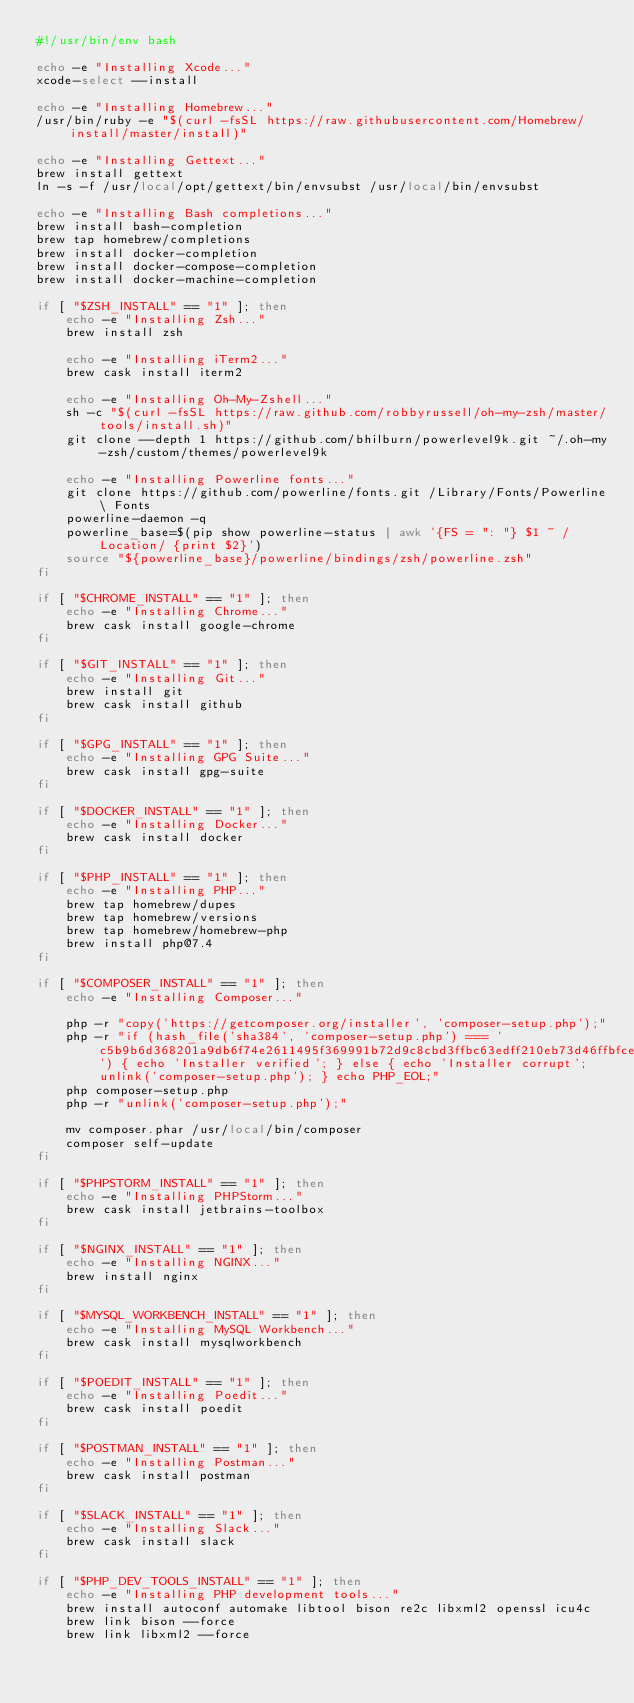<code> <loc_0><loc_0><loc_500><loc_500><_Bash_>#!/usr/bin/env bash

echo -e "Installing Xcode..."
xcode-select --install

echo -e "Installing Homebrew..."
/usr/bin/ruby -e "$(curl -fsSL https://raw.githubusercontent.com/Homebrew/install/master/install)"

echo -e "Installing Gettext..."
brew install gettext
ln -s -f /usr/local/opt/gettext/bin/envsubst /usr/local/bin/envsubst

echo -e "Installing Bash completions..."
brew install bash-completion
brew tap homebrew/completions
brew install docker-completion
brew install docker-compose-completion
brew install docker-machine-completion

if [ "$ZSH_INSTALL" == "1" ]; then
    echo -e "Installing Zsh..."
    brew install zsh

    echo -e "Installing iTerm2..."
    brew cask install iterm2

    echo -e "Installing Oh-My-Zshell..."
    sh -c "$(curl -fsSL https://raw.github.com/robbyrussell/oh-my-zsh/master/tools/install.sh)"
    git clone --depth 1 https://github.com/bhilburn/powerlevel9k.git ~/.oh-my-zsh/custom/themes/powerlevel9k

    echo -e "Installing Powerline fonts..."
    git clone https://github.com/powerline/fonts.git /Library/Fonts/Powerline\ Fonts
    powerline-daemon -q
    powerline_base=$(pip show powerline-status | awk '{FS = ": "} $1 ~ /Location/ {print $2}')
    source "${powerline_base}/powerline/bindings/zsh/powerline.zsh"
fi

if [ "$CHROME_INSTALL" == "1" ]; then
    echo -e "Installing Chrome..."
    brew cask install google-chrome
fi

if [ "$GIT_INSTALL" == "1" ]; then
    echo -e "Installing Git..."
    brew install git
    brew cask install github
fi

if [ "$GPG_INSTALL" == "1" ]; then
    echo -e "Installing GPG Suite..."
    brew cask install gpg-suite
fi

if [ "$DOCKER_INSTALL" == "1" ]; then
    echo -e "Installing Docker..."
    brew cask install docker
fi

if [ "$PHP_INSTALL" == "1" ]; then
    echo -e "Installing PHP..."
    brew tap homebrew/dupes
    brew tap homebrew/versions
    brew tap homebrew/homebrew-php
    brew install php@7.4
fi

if [ "$COMPOSER_INSTALL" == "1" ]; then
    echo -e "Installing Composer..."
    
    php -r "copy('https://getcomposer.org/installer', 'composer-setup.php');"
    php -r "if (hash_file('sha384', 'composer-setup.php') === 'c5b9b6d368201a9db6f74e2611495f369991b72d9c8cbd3ffbc63edff210eb73d46ffbfce88669ad33695ef77dc76976') { echo 'Installer verified'; } else { echo 'Installer corrupt'; unlink('composer-setup.php'); } echo PHP_EOL;"
    php composer-setup.php
    php -r "unlink('composer-setup.php');"

    mv composer.phar /usr/local/bin/composer
    composer self-update
fi

if [ "$PHPSTORM_INSTALL" == "1" ]; then
    echo -e "Installing PHPStorm..."
    brew cask install jetbrains-toolbox
fi

if [ "$NGINX_INSTALL" == "1" ]; then
    echo -e "Installing NGINX..."
    brew install nginx
fi

if [ "$MYSQL_WORKBENCH_INSTALL" == "1" ]; then
    echo -e "Installing MySQL Workbench..."
    brew cask install mysqlworkbench
fi

if [ "$POEDIT_INSTALL" == "1" ]; then
    echo -e "Installing Poedit..."
    brew cask install poedit
fi

if [ "$POSTMAN_INSTALL" == "1" ]; then
    echo -e "Installing Postman..."
    brew cask install postman
fi

if [ "$SLACK_INSTALL" == "1" ]; then
    echo -e "Installing Slack..."
    brew cask install slack
fi

if [ "$PHP_DEV_TOOLS_INSTALL" == "1" ]; then
    echo -e "Installing PHP development tools..."
    brew install autoconf automake libtool bison re2c libxml2 openssl icu4c
    brew link bison --force
    brew link libxml2 --force</code> 